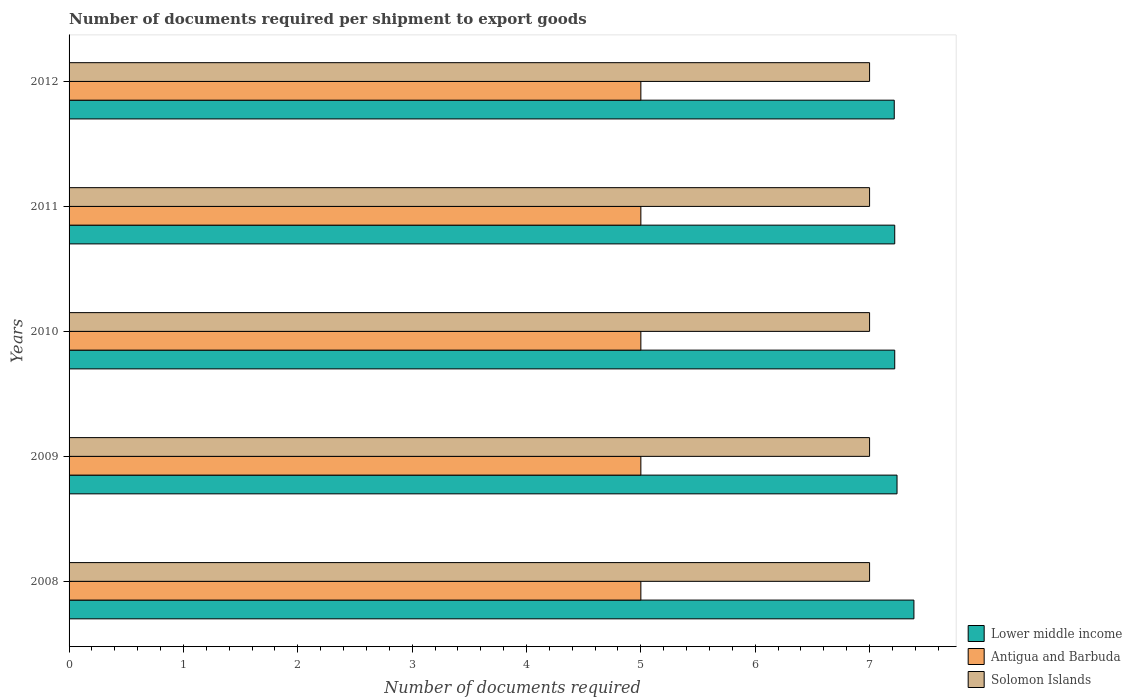How many different coloured bars are there?
Ensure brevity in your answer.  3. How many groups of bars are there?
Offer a very short reply. 5. How many bars are there on the 5th tick from the top?
Your answer should be very brief. 3. What is the number of documents required per shipment to export goods in Lower middle income in 2012?
Offer a very short reply. 7.22. Across all years, what is the maximum number of documents required per shipment to export goods in Lower middle income?
Make the answer very short. 7.39. Across all years, what is the minimum number of documents required per shipment to export goods in Solomon Islands?
Keep it short and to the point. 7. In which year was the number of documents required per shipment to export goods in Antigua and Barbuda minimum?
Make the answer very short. 2008. What is the total number of documents required per shipment to export goods in Lower middle income in the graph?
Offer a very short reply. 36.28. What is the difference between the number of documents required per shipment to export goods in Solomon Islands in 2008 and that in 2010?
Offer a terse response. 0. What is the difference between the number of documents required per shipment to export goods in Solomon Islands in 2010 and the number of documents required per shipment to export goods in Antigua and Barbuda in 2011?
Provide a succinct answer. 2. What is the average number of documents required per shipment to export goods in Antigua and Barbuda per year?
Your response must be concise. 5. In the year 2009, what is the difference between the number of documents required per shipment to export goods in Lower middle income and number of documents required per shipment to export goods in Solomon Islands?
Ensure brevity in your answer.  0.24. In how many years, is the number of documents required per shipment to export goods in Antigua and Barbuda greater than 2 ?
Your response must be concise. 5. What is the ratio of the number of documents required per shipment to export goods in Lower middle income in 2009 to that in 2011?
Offer a terse response. 1. Is the number of documents required per shipment to export goods in Antigua and Barbuda in 2011 less than that in 2012?
Your answer should be compact. No. Is the difference between the number of documents required per shipment to export goods in Lower middle income in 2009 and 2011 greater than the difference between the number of documents required per shipment to export goods in Solomon Islands in 2009 and 2011?
Your response must be concise. Yes. What is the difference between the highest and the lowest number of documents required per shipment to export goods in Solomon Islands?
Your answer should be very brief. 0. In how many years, is the number of documents required per shipment to export goods in Lower middle income greater than the average number of documents required per shipment to export goods in Lower middle income taken over all years?
Make the answer very short. 1. What does the 1st bar from the top in 2009 represents?
Your answer should be compact. Solomon Islands. What does the 2nd bar from the bottom in 2011 represents?
Make the answer very short. Antigua and Barbuda. Is it the case that in every year, the sum of the number of documents required per shipment to export goods in Antigua and Barbuda and number of documents required per shipment to export goods in Lower middle income is greater than the number of documents required per shipment to export goods in Solomon Islands?
Offer a very short reply. Yes. How many bars are there?
Provide a short and direct response. 15. Are all the bars in the graph horizontal?
Keep it short and to the point. Yes. How many years are there in the graph?
Offer a terse response. 5. Are the values on the major ticks of X-axis written in scientific E-notation?
Give a very brief answer. No. Does the graph contain grids?
Give a very brief answer. No. What is the title of the graph?
Keep it short and to the point. Number of documents required per shipment to export goods. Does "World" appear as one of the legend labels in the graph?
Offer a terse response. No. What is the label or title of the X-axis?
Keep it short and to the point. Number of documents required. What is the Number of documents required in Lower middle income in 2008?
Offer a very short reply. 7.39. What is the Number of documents required of Lower middle income in 2009?
Your response must be concise. 7.24. What is the Number of documents required in Lower middle income in 2010?
Your answer should be compact. 7.22. What is the Number of documents required in Solomon Islands in 2010?
Keep it short and to the point. 7. What is the Number of documents required of Lower middle income in 2011?
Offer a terse response. 7.22. What is the Number of documents required in Antigua and Barbuda in 2011?
Offer a very short reply. 5. What is the Number of documents required of Solomon Islands in 2011?
Your answer should be compact. 7. What is the Number of documents required in Lower middle income in 2012?
Offer a terse response. 7.22. What is the Number of documents required of Antigua and Barbuda in 2012?
Offer a terse response. 5. What is the Number of documents required in Solomon Islands in 2012?
Offer a terse response. 7. Across all years, what is the maximum Number of documents required in Lower middle income?
Your answer should be compact. 7.39. Across all years, what is the maximum Number of documents required in Solomon Islands?
Make the answer very short. 7. Across all years, what is the minimum Number of documents required in Lower middle income?
Provide a short and direct response. 7.22. What is the total Number of documents required in Lower middle income in the graph?
Provide a succinct answer. 36.28. What is the total Number of documents required in Antigua and Barbuda in the graph?
Your response must be concise. 25. What is the difference between the Number of documents required in Lower middle income in 2008 and that in 2009?
Provide a short and direct response. 0.15. What is the difference between the Number of documents required in Antigua and Barbuda in 2008 and that in 2009?
Make the answer very short. 0. What is the difference between the Number of documents required of Lower middle income in 2008 and that in 2010?
Offer a very short reply. 0.17. What is the difference between the Number of documents required in Solomon Islands in 2008 and that in 2010?
Give a very brief answer. 0. What is the difference between the Number of documents required of Lower middle income in 2008 and that in 2011?
Provide a succinct answer. 0.17. What is the difference between the Number of documents required of Antigua and Barbuda in 2008 and that in 2011?
Keep it short and to the point. 0. What is the difference between the Number of documents required of Lower middle income in 2008 and that in 2012?
Give a very brief answer. 0.17. What is the difference between the Number of documents required in Solomon Islands in 2008 and that in 2012?
Make the answer very short. 0. What is the difference between the Number of documents required of Solomon Islands in 2009 and that in 2010?
Your answer should be compact. 0. What is the difference between the Number of documents required in Solomon Islands in 2009 and that in 2011?
Offer a terse response. 0. What is the difference between the Number of documents required in Lower middle income in 2009 and that in 2012?
Make the answer very short. 0.02. What is the difference between the Number of documents required in Antigua and Barbuda in 2010 and that in 2011?
Make the answer very short. 0. What is the difference between the Number of documents required in Lower middle income in 2010 and that in 2012?
Your response must be concise. 0. What is the difference between the Number of documents required of Antigua and Barbuda in 2010 and that in 2012?
Your answer should be compact. 0. What is the difference between the Number of documents required of Solomon Islands in 2010 and that in 2012?
Keep it short and to the point. 0. What is the difference between the Number of documents required in Lower middle income in 2011 and that in 2012?
Provide a succinct answer. 0. What is the difference between the Number of documents required of Antigua and Barbuda in 2011 and that in 2012?
Provide a succinct answer. 0. What is the difference between the Number of documents required of Lower middle income in 2008 and the Number of documents required of Antigua and Barbuda in 2009?
Keep it short and to the point. 2.39. What is the difference between the Number of documents required of Lower middle income in 2008 and the Number of documents required of Solomon Islands in 2009?
Make the answer very short. 0.39. What is the difference between the Number of documents required in Lower middle income in 2008 and the Number of documents required in Antigua and Barbuda in 2010?
Provide a short and direct response. 2.39. What is the difference between the Number of documents required in Lower middle income in 2008 and the Number of documents required in Solomon Islands in 2010?
Make the answer very short. 0.39. What is the difference between the Number of documents required in Antigua and Barbuda in 2008 and the Number of documents required in Solomon Islands in 2010?
Your answer should be compact. -2. What is the difference between the Number of documents required in Lower middle income in 2008 and the Number of documents required in Antigua and Barbuda in 2011?
Make the answer very short. 2.39. What is the difference between the Number of documents required of Lower middle income in 2008 and the Number of documents required of Solomon Islands in 2011?
Provide a succinct answer. 0.39. What is the difference between the Number of documents required in Antigua and Barbuda in 2008 and the Number of documents required in Solomon Islands in 2011?
Ensure brevity in your answer.  -2. What is the difference between the Number of documents required in Lower middle income in 2008 and the Number of documents required in Antigua and Barbuda in 2012?
Ensure brevity in your answer.  2.39. What is the difference between the Number of documents required of Lower middle income in 2008 and the Number of documents required of Solomon Islands in 2012?
Give a very brief answer. 0.39. What is the difference between the Number of documents required in Antigua and Barbuda in 2008 and the Number of documents required in Solomon Islands in 2012?
Keep it short and to the point. -2. What is the difference between the Number of documents required in Lower middle income in 2009 and the Number of documents required in Antigua and Barbuda in 2010?
Keep it short and to the point. 2.24. What is the difference between the Number of documents required of Lower middle income in 2009 and the Number of documents required of Solomon Islands in 2010?
Keep it short and to the point. 0.24. What is the difference between the Number of documents required of Antigua and Barbuda in 2009 and the Number of documents required of Solomon Islands in 2010?
Keep it short and to the point. -2. What is the difference between the Number of documents required in Lower middle income in 2009 and the Number of documents required in Antigua and Barbuda in 2011?
Make the answer very short. 2.24. What is the difference between the Number of documents required of Lower middle income in 2009 and the Number of documents required of Solomon Islands in 2011?
Ensure brevity in your answer.  0.24. What is the difference between the Number of documents required of Antigua and Barbuda in 2009 and the Number of documents required of Solomon Islands in 2011?
Keep it short and to the point. -2. What is the difference between the Number of documents required in Lower middle income in 2009 and the Number of documents required in Antigua and Barbuda in 2012?
Give a very brief answer. 2.24. What is the difference between the Number of documents required in Lower middle income in 2009 and the Number of documents required in Solomon Islands in 2012?
Offer a terse response. 0.24. What is the difference between the Number of documents required in Lower middle income in 2010 and the Number of documents required in Antigua and Barbuda in 2011?
Your answer should be very brief. 2.22. What is the difference between the Number of documents required in Lower middle income in 2010 and the Number of documents required in Solomon Islands in 2011?
Provide a succinct answer. 0.22. What is the difference between the Number of documents required of Antigua and Barbuda in 2010 and the Number of documents required of Solomon Islands in 2011?
Make the answer very short. -2. What is the difference between the Number of documents required in Lower middle income in 2010 and the Number of documents required in Antigua and Barbuda in 2012?
Ensure brevity in your answer.  2.22. What is the difference between the Number of documents required of Lower middle income in 2010 and the Number of documents required of Solomon Islands in 2012?
Give a very brief answer. 0.22. What is the difference between the Number of documents required in Antigua and Barbuda in 2010 and the Number of documents required in Solomon Islands in 2012?
Offer a terse response. -2. What is the difference between the Number of documents required in Lower middle income in 2011 and the Number of documents required in Antigua and Barbuda in 2012?
Provide a succinct answer. 2.22. What is the difference between the Number of documents required in Lower middle income in 2011 and the Number of documents required in Solomon Islands in 2012?
Offer a terse response. 0.22. What is the average Number of documents required of Lower middle income per year?
Provide a succinct answer. 7.26. What is the average Number of documents required of Solomon Islands per year?
Provide a succinct answer. 7. In the year 2008, what is the difference between the Number of documents required of Lower middle income and Number of documents required of Antigua and Barbuda?
Provide a succinct answer. 2.39. In the year 2008, what is the difference between the Number of documents required of Lower middle income and Number of documents required of Solomon Islands?
Offer a very short reply. 0.39. In the year 2008, what is the difference between the Number of documents required of Antigua and Barbuda and Number of documents required of Solomon Islands?
Ensure brevity in your answer.  -2. In the year 2009, what is the difference between the Number of documents required of Lower middle income and Number of documents required of Antigua and Barbuda?
Offer a terse response. 2.24. In the year 2009, what is the difference between the Number of documents required of Lower middle income and Number of documents required of Solomon Islands?
Provide a short and direct response. 0.24. In the year 2009, what is the difference between the Number of documents required in Antigua and Barbuda and Number of documents required in Solomon Islands?
Make the answer very short. -2. In the year 2010, what is the difference between the Number of documents required of Lower middle income and Number of documents required of Antigua and Barbuda?
Offer a terse response. 2.22. In the year 2010, what is the difference between the Number of documents required in Lower middle income and Number of documents required in Solomon Islands?
Your response must be concise. 0.22. In the year 2011, what is the difference between the Number of documents required of Lower middle income and Number of documents required of Antigua and Barbuda?
Keep it short and to the point. 2.22. In the year 2011, what is the difference between the Number of documents required of Lower middle income and Number of documents required of Solomon Islands?
Offer a very short reply. 0.22. In the year 2011, what is the difference between the Number of documents required in Antigua and Barbuda and Number of documents required in Solomon Islands?
Your answer should be very brief. -2. In the year 2012, what is the difference between the Number of documents required in Lower middle income and Number of documents required in Antigua and Barbuda?
Your response must be concise. 2.22. In the year 2012, what is the difference between the Number of documents required in Lower middle income and Number of documents required in Solomon Islands?
Your answer should be very brief. 0.22. In the year 2012, what is the difference between the Number of documents required in Antigua and Barbuda and Number of documents required in Solomon Islands?
Your answer should be compact. -2. What is the ratio of the Number of documents required in Lower middle income in 2008 to that in 2009?
Provide a succinct answer. 1.02. What is the ratio of the Number of documents required of Lower middle income in 2008 to that in 2010?
Your answer should be very brief. 1.02. What is the ratio of the Number of documents required of Solomon Islands in 2008 to that in 2010?
Provide a short and direct response. 1. What is the ratio of the Number of documents required of Lower middle income in 2008 to that in 2011?
Give a very brief answer. 1.02. What is the ratio of the Number of documents required in Antigua and Barbuda in 2008 to that in 2011?
Offer a terse response. 1. What is the ratio of the Number of documents required of Solomon Islands in 2008 to that in 2011?
Keep it short and to the point. 1. What is the ratio of the Number of documents required of Lower middle income in 2008 to that in 2012?
Keep it short and to the point. 1.02. What is the ratio of the Number of documents required of Antigua and Barbuda in 2008 to that in 2012?
Offer a very short reply. 1. What is the ratio of the Number of documents required of Solomon Islands in 2008 to that in 2012?
Offer a terse response. 1. What is the ratio of the Number of documents required in Antigua and Barbuda in 2009 to that in 2010?
Your response must be concise. 1. What is the ratio of the Number of documents required of Solomon Islands in 2009 to that in 2012?
Keep it short and to the point. 1. What is the ratio of the Number of documents required in Antigua and Barbuda in 2010 to that in 2011?
Keep it short and to the point. 1. What is the ratio of the Number of documents required of Solomon Islands in 2010 to that in 2011?
Offer a very short reply. 1. What is the ratio of the Number of documents required in Lower middle income in 2010 to that in 2012?
Your answer should be compact. 1. What is the ratio of the Number of documents required of Solomon Islands in 2010 to that in 2012?
Provide a succinct answer. 1. What is the ratio of the Number of documents required in Lower middle income in 2011 to that in 2012?
Make the answer very short. 1. What is the difference between the highest and the second highest Number of documents required of Lower middle income?
Your answer should be very brief. 0.15. What is the difference between the highest and the second highest Number of documents required in Solomon Islands?
Your answer should be compact. 0. What is the difference between the highest and the lowest Number of documents required of Lower middle income?
Provide a succinct answer. 0.17. What is the difference between the highest and the lowest Number of documents required in Antigua and Barbuda?
Provide a succinct answer. 0. 